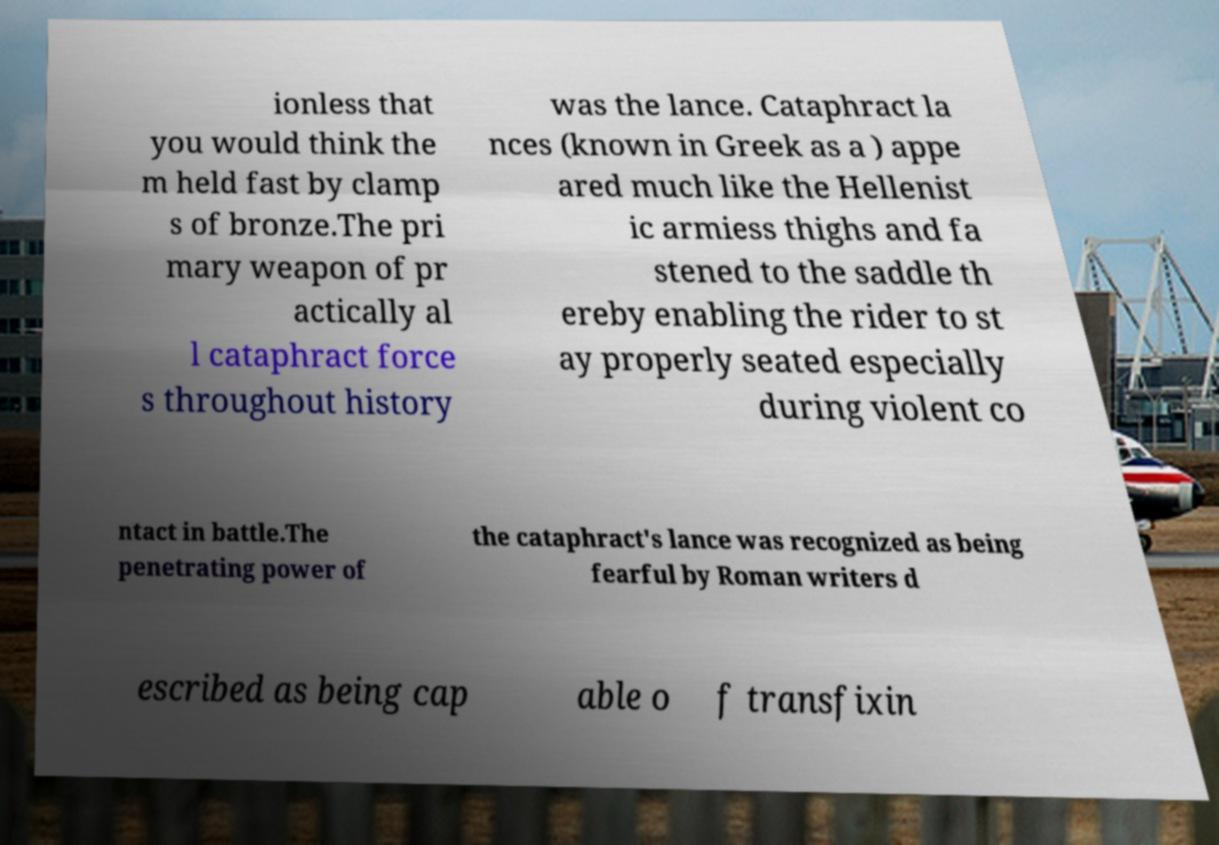Could you assist in decoding the text presented in this image and type it out clearly? ionless that you would think the m held fast by clamp s of bronze.The pri mary weapon of pr actically al l cataphract force s throughout history was the lance. Cataphract la nces (known in Greek as a ) appe ared much like the Hellenist ic armiess thighs and fa stened to the saddle th ereby enabling the rider to st ay properly seated especially during violent co ntact in battle.The penetrating power of the cataphract's lance was recognized as being fearful by Roman writers d escribed as being cap able o f transfixin 